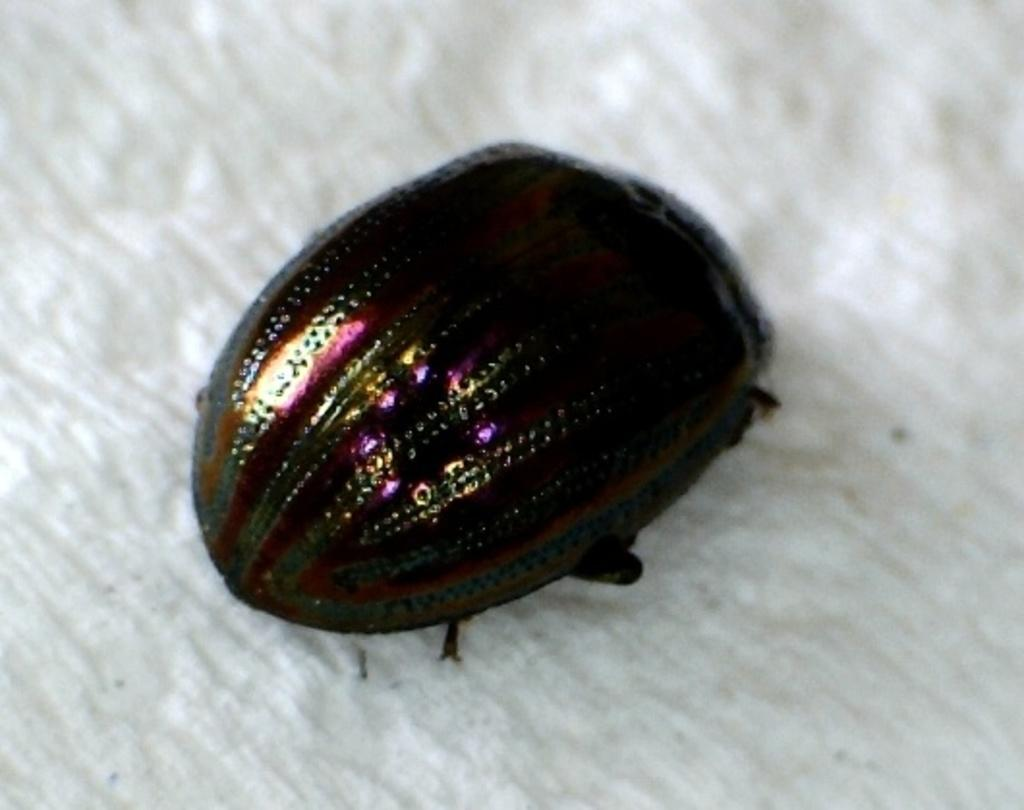What type of creature can be seen in the image? There is an insect in the image. Where is the insect located? The insect is on a white color blanket or other object. What type of stocking is the queen wearing in the image? There is no queen or stocking present in the image; it features an insect on a white color blanket or other object. 